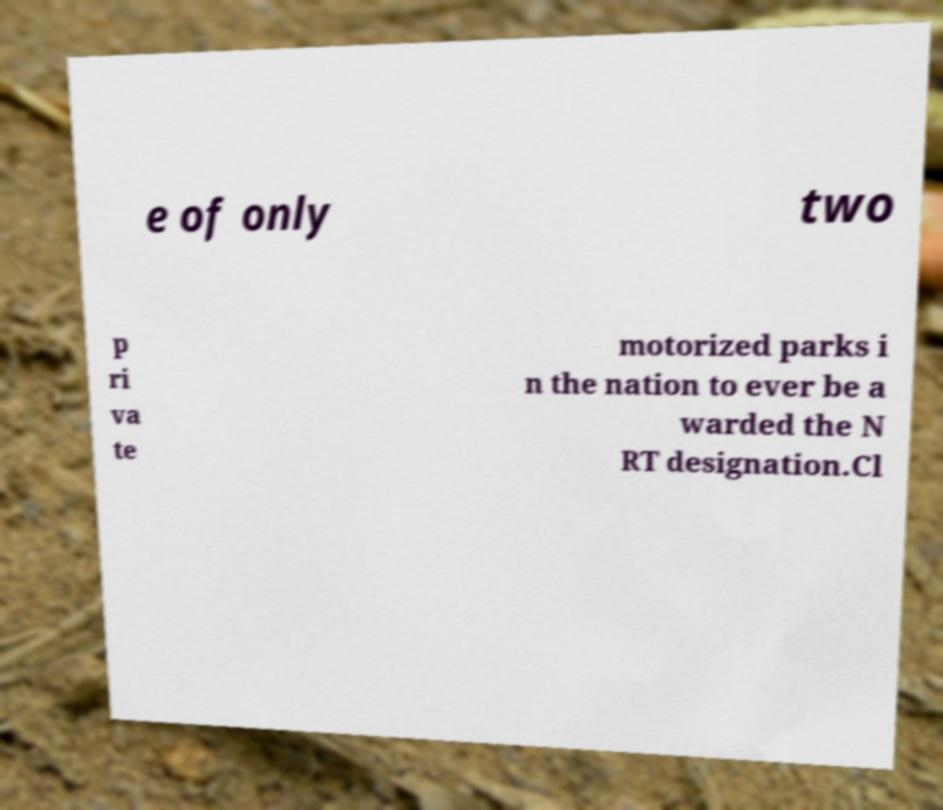I need the written content from this picture converted into text. Can you do that? e of only two p ri va te motorized parks i n the nation to ever be a warded the N RT designation.Cl 